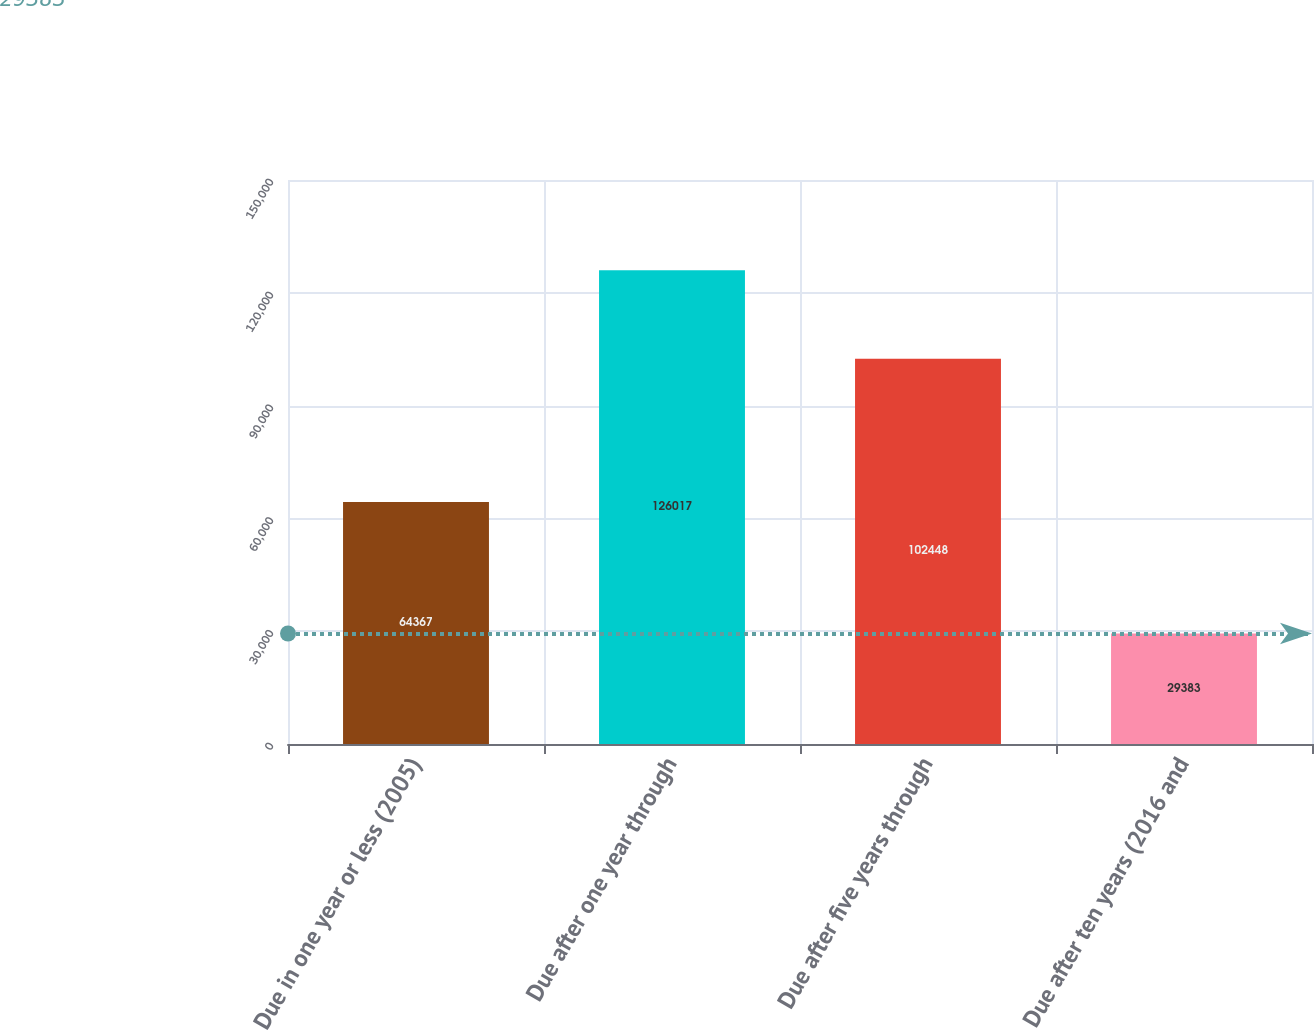Convert chart to OTSL. <chart><loc_0><loc_0><loc_500><loc_500><bar_chart><fcel>Due in one year or less (2005)<fcel>Due after one year through<fcel>Due after five years through<fcel>Due after ten years (2016 and<nl><fcel>64367<fcel>126017<fcel>102448<fcel>29383<nl></chart> 